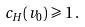<formula> <loc_0><loc_0><loc_500><loc_500>c _ { H } ( v _ { 0 } ) & \geqslant 1 \, .</formula> 